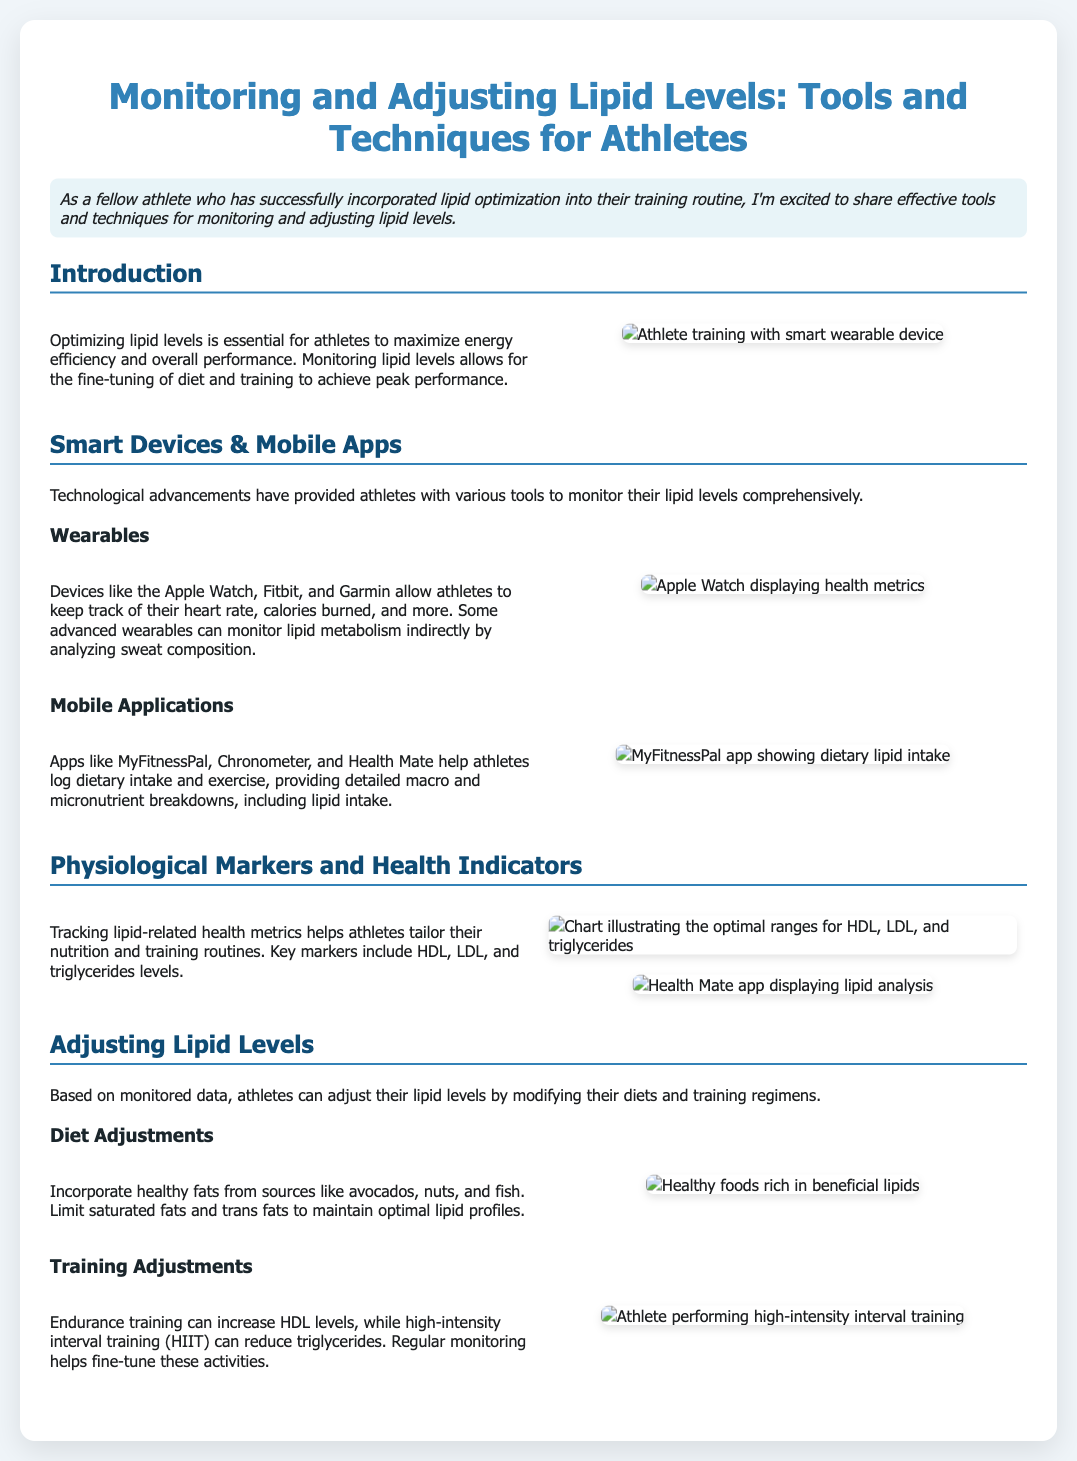What is the focus of the slide? The slide focuses on tools and techniques for monitoring and adjusting lipid levels for athletes.
Answer: Monitoring and adjusting lipid levels What are some examples of wearables mentioned? The slide mentions specific brands of smart devices that athletes can use to monitor their health metrics.
Answer: Apple Watch, Fitbit, Garmin What is a key health marker tracked in the document? The document lists important physiological markers that athletes should monitor related to lipids.
Answer: HDL, LDL, triglycerides Which app is shown for logging dietary intake? The slide displays a specific application as a useful tool for athletes to track their macro and micronutrient intake.
Answer: MyFitnessPal What type of training can increase HDL levels? The document specifies a type of training that positively impacts lipid levels in athletes.
Answer: Endurance training What should be limited in the diet to maintain optimal lipid profiles? The slide provides dietary advice for athletes regarding lipid intake.
Answer: Saturated fats, trans fats Which food source is recommended for healthy fats? The document suggests specific food sources that provide beneficial lipids.
Answer: Avocados, nuts, fish What visual aid illustrates optimal ranges for lipid markers? The slide features a chart that visually represents the healthy ranges for specific lipid markers.
Answer: Lipid markers chart 